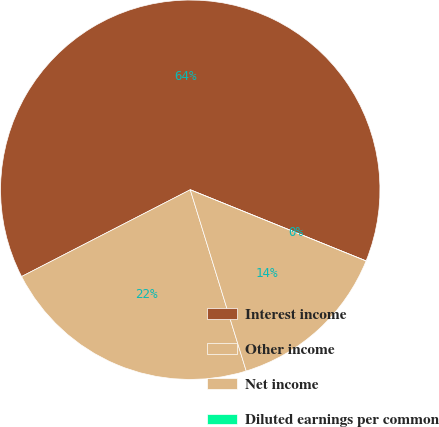Convert chart. <chart><loc_0><loc_0><loc_500><loc_500><pie_chart><fcel>Interest income<fcel>Other income<fcel>Net income<fcel>Diluted earnings per common<nl><fcel>63.68%<fcel>22.2%<fcel>14.11%<fcel>0.0%<nl></chart> 